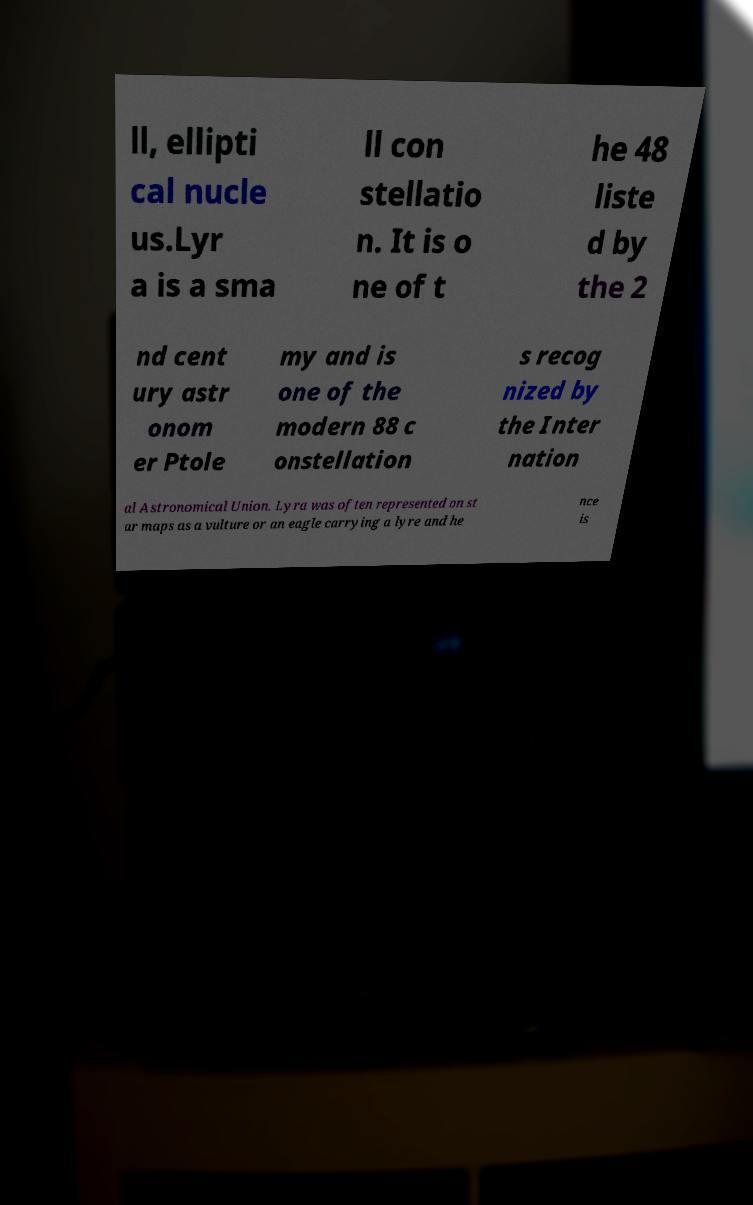For documentation purposes, I need the text within this image transcribed. Could you provide that? ll, ellipti cal nucle us.Lyr a is a sma ll con stellatio n. It is o ne of t he 48 liste d by the 2 nd cent ury astr onom er Ptole my and is one of the modern 88 c onstellation s recog nized by the Inter nation al Astronomical Union. Lyra was often represented on st ar maps as a vulture or an eagle carrying a lyre and he nce is 